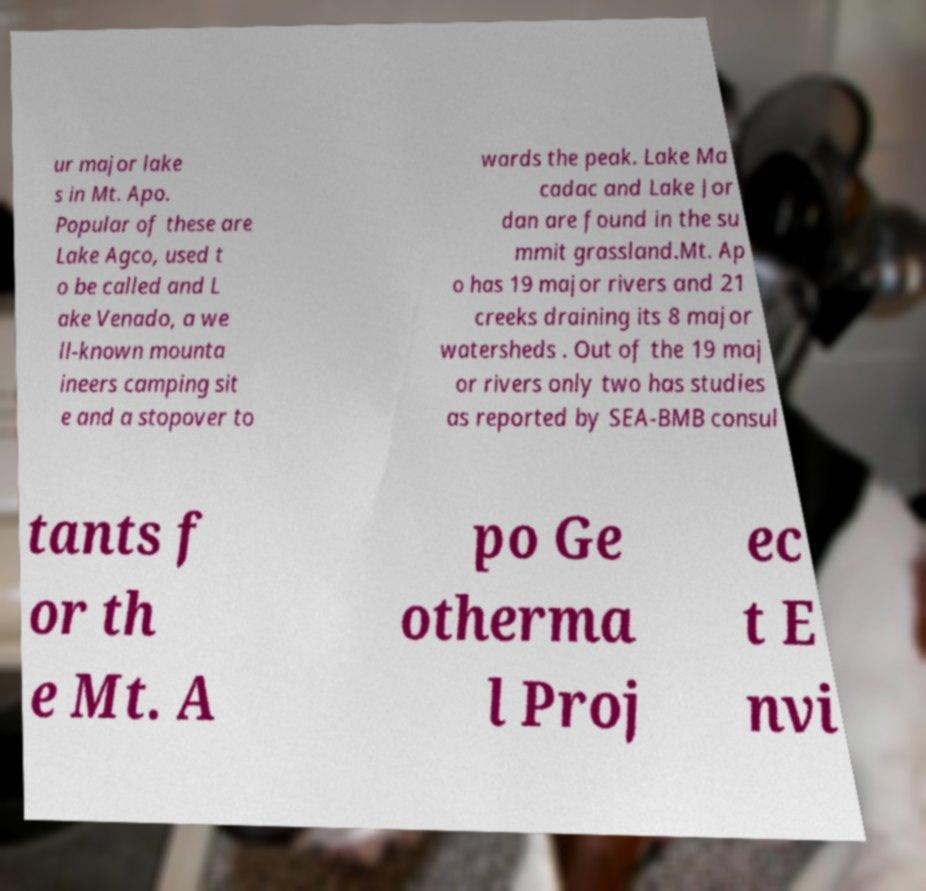What messages or text are displayed in this image? I need them in a readable, typed format. ur major lake s in Mt. Apo. Popular of these are Lake Agco, used t o be called and L ake Venado, a we ll-known mounta ineers camping sit e and a stopover to wards the peak. Lake Ma cadac and Lake Jor dan are found in the su mmit grassland.Mt. Ap o has 19 major rivers and 21 creeks draining its 8 major watersheds . Out of the 19 maj or rivers only two has studies as reported by SEA-BMB consul tants f or th e Mt. A po Ge otherma l Proj ec t E nvi 